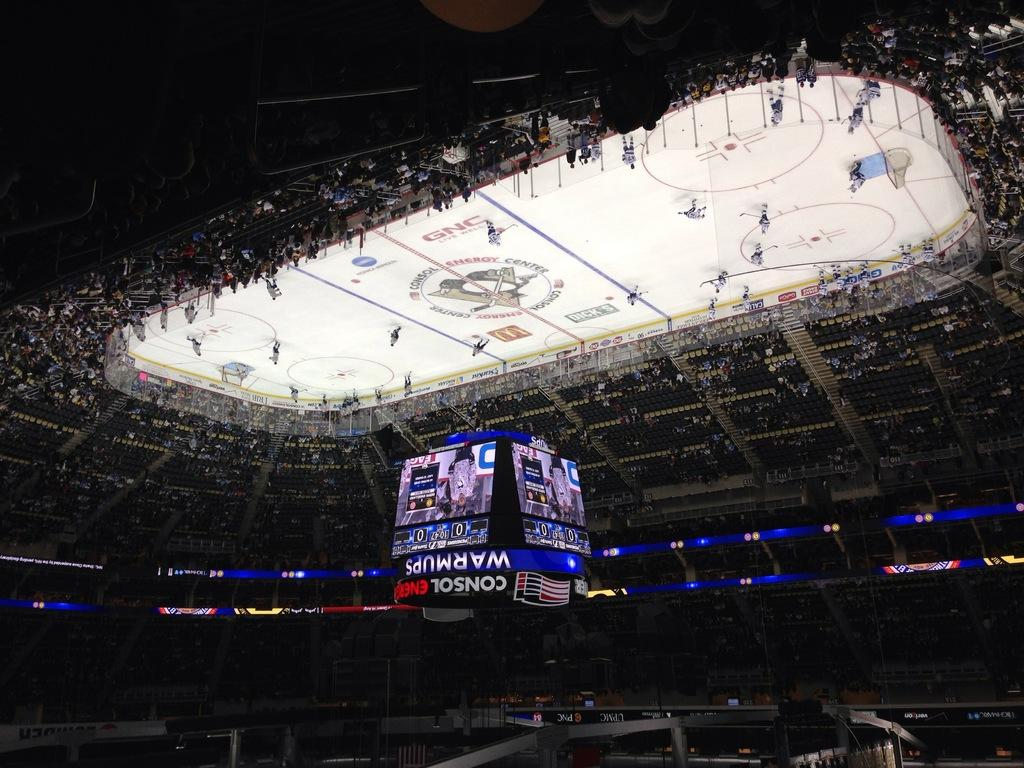<image>
Create a compact narrative representing the image presented. An overhead view of a hockey rink with the scoreboard showing advertising from Consol. 